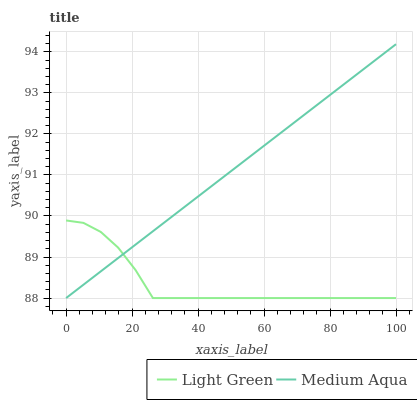Does Light Green have the minimum area under the curve?
Answer yes or no. Yes. Does Medium Aqua have the maximum area under the curve?
Answer yes or no. Yes. Does Light Green have the maximum area under the curve?
Answer yes or no. No. Is Medium Aqua the smoothest?
Answer yes or no. Yes. Is Light Green the roughest?
Answer yes or no. Yes. Is Light Green the smoothest?
Answer yes or no. No. Does Medium Aqua have the lowest value?
Answer yes or no. Yes. Does Medium Aqua have the highest value?
Answer yes or no. Yes. Does Light Green have the highest value?
Answer yes or no. No. Does Light Green intersect Medium Aqua?
Answer yes or no. Yes. Is Light Green less than Medium Aqua?
Answer yes or no. No. Is Light Green greater than Medium Aqua?
Answer yes or no. No. 